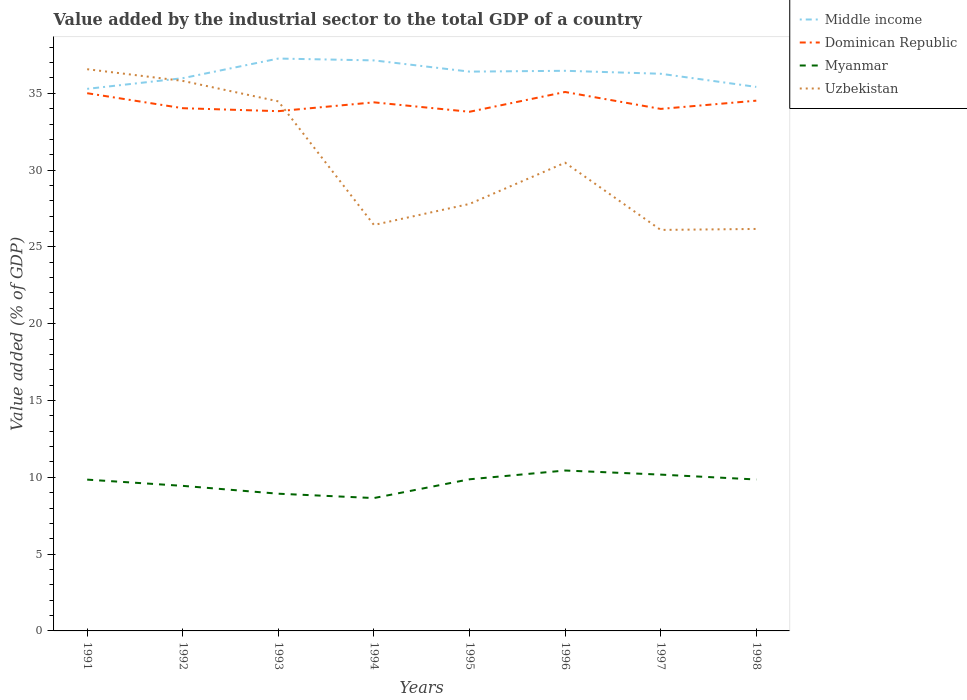How many different coloured lines are there?
Provide a succinct answer. 4. Does the line corresponding to Uzbekistan intersect with the line corresponding to Dominican Republic?
Make the answer very short. Yes. Is the number of lines equal to the number of legend labels?
Ensure brevity in your answer.  Yes. Across all years, what is the maximum value added by the industrial sector to the total GDP in Uzbekistan?
Offer a terse response. 26.11. What is the total value added by the industrial sector to the total GDP in Middle income in the graph?
Ensure brevity in your answer.  1.73. What is the difference between the highest and the second highest value added by the industrial sector to the total GDP in Uzbekistan?
Provide a succinct answer. 10.46. What is the difference between the highest and the lowest value added by the industrial sector to the total GDP in Dominican Republic?
Make the answer very short. 4. Does the graph contain grids?
Offer a very short reply. No. Where does the legend appear in the graph?
Keep it short and to the point. Top right. How many legend labels are there?
Offer a terse response. 4. What is the title of the graph?
Keep it short and to the point. Value added by the industrial sector to the total GDP of a country. Does "Lebanon" appear as one of the legend labels in the graph?
Your answer should be compact. No. What is the label or title of the Y-axis?
Make the answer very short. Value added (% of GDP). What is the Value added (% of GDP) in Middle income in 1991?
Your answer should be compact. 35.29. What is the Value added (% of GDP) in Dominican Republic in 1991?
Ensure brevity in your answer.  35. What is the Value added (% of GDP) in Myanmar in 1991?
Offer a terse response. 9.85. What is the Value added (% of GDP) in Uzbekistan in 1991?
Your answer should be compact. 36.57. What is the Value added (% of GDP) in Middle income in 1992?
Offer a very short reply. 35.98. What is the Value added (% of GDP) in Dominican Republic in 1992?
Make the answer very short. 34.03. What is the Value added (% of GDP) in Myanmar in 1992?
Make the answer very short. 9.44. What is the Value added (% of GDP) of Uzbekistan in 1992?
Your response must be concise. 35.81. What is the Value added (% of GDP) in Middle income in 1993?
Ensure brevity in your answer.  37.26. What is the Value added (% of GDP) in Dominican Republic in 1993?
Your answer should be compact. 33.84. What is the Value added (% of GDP) in Myanmar in 1993?
Give a very brief answer. 8.93. What is the Value added (% of GDP) in Uzbekistan in 1993?
Provide a succinct answer. 34.47. What is the Value added (% of GDP) of Middle income in 1994?
Make the answer very short. 37.14. What is the Value added (% of GDP) in Dominican Republic in 1994?
Your answer should be very brief. 34.41. What is the Value added (% of GDP) of Myanmar in 1994?
Your answer should be very brief. 8.65. What is the Value added (% of GDP) of Uzbekistan in 1994?
Make the answer very short. 26.43. What is the Value added (% of GDP) in Middle income in 1995?
Make the answer very short. 36.41. What is the Value added (% of GDP) in Dominican Republic in 1995?
Your answer should be very brief. 33.8. What is the Value added (% of GDP) in Myanmar in 1995?
Provide a short and direct response. 9.87. What is the Value added (% of GDP) in Uzbekistan in 1995?
Keep it short and to the point. 27.8. What is the Value added (% of GDP) in Middle income in 1996?
Keep it short and to the point. 36.46. What is the Value added (% of GDP) of Dominican Republic in 1996?
Keep it short and to the point. 35.08. What is the Value added (% of GDP) of Myanmar in 1996?
Your answer should be very brief. 10.44. What is the Value added (% of GDP) of Uzbekistan in 1996?
Your response must be concise. 30.48. What is the Value added (% of GDP) in Middle income in 1997?
Keep it short and to the point. 36.27. What is the Value added (% of GDP) of Dominican Republic in 1997?
Provide a short and direct response. 33.98. What is the Value added (% of GDP) of Myanmar in 1997?
Ensure brevity in your answer.  10.18. What is the Value added (% of GDP) of Uzbekistan in 1997?
Give a very brief answer. 26.11. What is the Value added (% of GDP) of Middle income in 1998?
Offer a very short reply. 35.42. What is the Value added (% of GDP) of Dominican Republic in 1998?
Give a very brief answer. 34.52. What is the Value added (% of GDP) of Myanmar in 1998?
Provide a succinct answer. 9.86. What is the Value added (% of GDP) in Uzbekistan in 1998?
Your answer should be very brief. 26.17. Across all years, what is the maximum Value added (% of GDP) of Middle income?
Offer a very short reply. 37.26. Across all years, what is the maximum Value added (% of GDP) of Dominican Republic?
Make the answer very short. 35.08. Across all years, what is the maximum Value added (% of GDP) in Myanmar?
Give a very brief answer. 10.44. Across all years, what is the maximum Value added (% of GDP) of Uzbekistan?
Make the answer very short. 36.57. Across all years, what is the minimum Value added (% of GDP) of Middle income?
Ensure brevity in your answer.  35.29. Across all years, what is the minimum Value added (% of GDP) of Dominican Republic?
Provide a short and direct response. 33.8. Across all years, what is the minimum Value added (% of GDP) of Myanmar?
Your answer should be very brief. 8.65. Across all years, what is the minimum Value added (% of GDP) of Uzbekistan?
Offer a very short reply. 26.11. What is the total Value added (% of GDP) in Middle income in the graph?
Provide a succinct answer. 290.23. What is the total Value added (% of GDP) in Dominican Republic in the graph?
Give a very brief answer. 274.66. What is the total Value added (% of GDP) in Myanmar in the graph?
Give a very brief answer. 77.22. What is the total Value added (% of GDP) of Uzbekistan in the graph?
Offer a very short reply. 243.83. What is the difference between the Value added (% of GDP) in Middle income in 1991 and that in 1992?
Ensure brevity in your answer.  -0.7. What is the difference between the Value added (% of GDP) in Dominican Republic in 1991 and that in 1992?
Keep it short and to the point. 0.98. What is the difference between the Value added (% of GDP) in Myanmar in 1991 and that in 1992?
Ensure brevity in your answer.  0.41. What is the difference between the Value added (% of GDP) of Uzbekistan in 1991 and that in 1992?
Offer a terse response. 0.76. What is the difference between the Value added (% of GDP) in Middle income in 1991 and that in 1993?
Make the answer very short. -1.97. What is the difference between the Value added (% of GDP) in Dominican Republic in 1991 and that in 1993?
Make the answer very short. 1.17. What is the difference between the Value added (% of GDP) of Myanmar in 1991 and that in 1993?
Keep it short and to the point. 0.92. What is the difference between the Value added (% of GDP) of Uzbekistan in 1991 and that in 1993?
Provide a short and direct response. 2.09. What is the difference between the Value added (% of GDP) of Middle income in 1991 and that in 1994?
Provide a short and direct response. -1.85. What is the difference between the Value added (% of GDP) of Dominican Republic in 1991 and that in 1994?
Provide a short and direct response. 0.59. What is the difference between the Value added (% of GDP) of Uzbekistan in 1991 and that in 1994?
Offer a very short reply. 10.14. What is the difference between the Value added (% of GDP) in Middle income in 1991 and that in 1995?
Offer a very short reply. -1.12. What is the difference between the Value added (% of GDP) in Dominican Republic in 1991 and that in 1995?
Provide a short and direct response. 1.21. What is the difference between the Value added (% of GDP) in Myanmar in 1991 and that in 1995?
Your response must be concise. -0.02. What is the difference between the Value added (% of GDP) of Uzbekistan in 1991 and that in 1995?
Your answer should be very brief. 8.77. What is the difference between the Value added (% of GDP) in Middle income in 1991 and that in 1996?
Provide a short and direct response. -1.18. What is the difference between the Value added (% of GDP) in Dominican Republic in 1991 and that in 1996?
Offer a terse response. -0.08. What is the difference between the Value added (% of GDP) of Myanmar in 1991 and that in 1996?
Ensure brevity in your answer.  -0.59. What is the difference between the Value added (% of GDP) in Uzbekistan in 1991 and that in 1996?
Give a very brief answer. 6.09. What is the difference between the Value added (% of GDP) in Middle income in 1991 and that in 1997?
Your answer should be very brief. -0.98. What is the difference between the Value added (% of GDP) in Dominican Republic in 1991 and that in 1997?
Your response must be concise. 1.02. What is the difference between the Value added (% of GDP) of Myanmar in 1991 and that in 1997?
Make the answer very short. -0.33. What is the difference between the Value added (% of GDP) of Uzbekistan in 1991 and that in 1997?
Provide a short and direct response. 10.46. What is the difference between the Value added (% of GDP) in Middle income in 1991 and that in 1998?
Ensure brevity in your answer.  -0.13. What is the difference between the Value added (% of GDP) in Dominican Republic in 1991 and that in 1998?
Ensure brevity in your answer.  0.49. What is the difference between the Value added (% of GDP) in Myanmar in 1991 and that in 1998?
Give a very brief answer. -0.01. What is the difference between the Value added (% of GDP) of Uzbekistan in 1991 and that in 1998?
Provide a succinct answer. 10.4. What is the difference between the Value added (% of GDP) in Middle income in 1992 and that in 1993?
Offer a very short reply. -1.28. What is the difference between the Value added (% of GDP) in Dominican Republic in 1992 and that in 1993?
Provide a succinct answer. 0.19. What is the difference between the Value added (% of GDP) of Myanmar in 1992 and that in 1993?
Offer a terse response. 0.51. What is the difference between the Value added (% of GDP) in Uzbekistan in 1992 and that in 1993?
Your response must be concise. 1.33. What is the difference between the Value added (% of GDP) of Middle income in 1992 and that in 1994?
Keep it short and to the point. -1.16. What is the difference between the Value added (% of GDP) of Dominican Republic in 1992 and that in 1994?
Give a very brief answer. -0.38. What is the difference between the Value added (% of GDP) in Myanmar in 1992 and that in 1994?
Your answer should be very brief. 0.79. What is the difference between the Value added (% of GDP) in Uzbekistan in 1992 and that in 1994?
Ensure brevity in your answer.  9.38. What is the difference between the Value added (% of GDP) of Middle income in 1992 and that in 1995?
Give a very brief answer. -0.43. What is the difference between the Value added (% of GDP) of Dominican Republic in 1992 and that in 1995?
Provide a short and direct response. 0.23. What is the difference between the Value added (% of GDP) of Myanmar in 1992 and that in 1995?
Make the answer very short. -0.43. What is the difference between the Value added (% of GDP) of Uzbekistan in 1992 and that in 1995?
Your answer should be very brief. 8.01. What is the difference between the Value added (% of GDP) of Middle income in 1992 and that in 1996?
Provide a short and direct response. -0.48. What is the difference between the Value added (% of GDP) of Dominican Republic in 1992 and that in 1996?
Your answer should be very brief. -1.06. What is the difference between the Value added (% of GDP) in Myanmar in 1992 and that in 1996?
Offer a very short reply. -1. What is the difference between the Value added (% of GDP) in Uzbekistan in 1992 and that in 1996?
Your answer should be compact. 5.33. What is the difference between the Value added (% of GDP) in Middle income in 1992 and that in 1997?
Offer a very short reply. -0.29. What is the difference between the Value added (% of GDP) in Dominican Republic in 1992 and that in 1997?
Provide a short and direct response. 0.05. What is the difference between the Value added (% of GDP) in Myanmar in 1992 and that in 1997?
Provide a succinct answer. -0.73. What is the difference between the Value added (% of GDP) of Uzbekistan in 1992 and that in 1997?
Make the answer very short. 9.7. What is the difference between the Value added (% of GDP) in Middle income in 1992 and that in 1998?
Your answer should be compact. 0.57. What is the difference between the Value added (% of GDP) of Dominican Republic in 1992 and that in 1998?
Ensure brevity in your answer.  -0.49. What is the difference between the Value added (% of GDP) in Myanmar in 1992 and that in 1998?
Provide a short and direct response. -0.41. What is the difference between the Value added (% of GDP) in Uzbekistan in 1992 and that in 1998?
Your answer should be very brief. 9.64. What is the difference between the Value added (% of GDP) of Middle income in 1993 and that in 1994?
Provide a short and direct response. 0.12. What is the difference between the Value added (% of GDP) in Dominican Republic in 1993 and that in 1994?
Your response must be concise. -0.57. What is the difference between the Value added (% of GDP) in Myanmar in 1993 and that in 1994?
Your answer should be very brief. 0.28. What is the difference between the Value added (% of GDP) in Uzbekistan in 1993 and that in 1994?
Make the answer very short. 8.05. What is the difference between the Value added (% of GDP) in Middle income in 1993 and that in 1995?
Give a very brief answer. 0.85. What is the difference between the Value added (% of GDP) of Dominican Republic in 1993 and that in 1995?
Keep it short and to the point. 0.04. What is the difference between the Value added (% of GDP) of Myanmar in 1993 and that in 1995?
Provide a succinct answer. -0.94. What is the difference between the Value added (% of GDP) in Uzbekistan in 1993 and that in 1995?
Your response must be concise. 6.68. What is the difference between the Value added (% of GDP) of Middle income in 1993 and that in 1996?
Provide a succinct answer. 0.8. What is the difference between the Value added (% of GDP) of Dominican Republic in 1993 and that in 1996?
Provide a succinct answer. -1.25. What is the difference between the Value added (% of GDP) of Myanmar in 1993 and that in 1996?
Provide a short and direct response. -1.51. What is the difference between the Value added (% of GDP) in Uzbekistan in 1993 and that in 1996?
Make the answer very short. 3.99. What is the difference between the Value added (% of GDP) in Dominican Republic in 1993 and that in 1997?
Give a very brief answer. -0.15. What is the difference between the Value added (% of GDP) in Myanmar in 1993 and that in 1997?
Keep it short and to the point. -1.24. What is the difference between the Value added (% of GDP) of Uzbekistan in 1993 and that in 1997?
Your response must be concise. 8.37. What is the difference between the Value added (% of GDP) of Middle income in 1993 and that in 1998?
Give a very brief answer. 1.85. What is the difference between the Value added (% of GDP) in Dominican Republic in 1993 and that in 1998?
Your answer should be compact. -0.68. What is the difference between the Value added (% of GDP) of Myanmar in 1993 and that in 1998?
Provide a short and direct response. -0.93. What is the difference between the Value added (% of GDP) in Uzbekistan in 1993 and that in 1998?
Ensure brevity in your answer.  8.31. What is the difference between the Value added (% of GDP) in Middle income in 1994 and that in 1995?
Provide a short and direct response. 0.73. What is the difference between the Value added (% of GDP) in Dominican Republic in 1994 and that in 1995?
Your answer should be compact. 0.61. What is the difference between the Value added (% of GDP) of Myanmar in 1994 and that in 1995?
Your answer should be very brief. -1.22. What is the difference between the Value added (% of GDP) of Uzbekistan in 1994 and that in 1995?
Keep it short and to the point. -1.37. What is the difference between the Value added (% of GDP) of Middle income in 1994 and that in 1996?
Provide a short and direct response. 0.68. What is the difference between the Value added (% of GDP) of Dominican Republic in 1994 and that in 1996?
Provide a short and direct response. -0.67. What is the difference between the Value added (% of GDP) in Myanmar in 1994 and that in 1996?
Your answer should be compact. -1.79. What is the difference between the Value added (% of GDP) in Uzbekistan in 1994 and that in 1996?
Offer a terse response. -4.05. What is the difference between the Value added (% of GDP) of Middle income in 1994 and that in 1997?
Keep it short and to the point. 0.87. What is the difference between the Value added (% of GDP) in Dominican Republic in 1994 and that in 1997?
Provide a succinct answer. 0.43. What is the difference between the Value added (% of GDP) in Myanmar in 1994 and that in 1997?
Your response must be concise. -1.53. What is the difference between the Value added (% of GDP) in Uzbekistan in 1994 and that in 1997?
Ensure brevity in your answer.  0.32. What is the difference between the Value added (% of GDP) in Middle income in 1994 and that in 1998?
Give a very brief answer. 1.73. What is the difference between the Value added (% of GDP) of Dominican Republic in 1994 and that in 1998?
Offer a very short reply. -0.11. What is the difference between the Value added (% of GDP) of Myanmar in 1994 and that in 1998?
Keep it short and to the point. -1.21. What is the difference between the Value added (% of GDP) in Uzbekistan in 1994 and that in 1998?
Your answer should be compact. 0.26. What is the difference between the Value added (% of GDP) of Middle income in 1995 and that in 1996?
Make the answer very short. -0.05. What is the difference between the Value added (% of GDP) of Dominican Republic in 1995 and that in 1996?
Ensure brevity in your answer.  -1.29. What is the difference between the Value added (% of GDP) in Myanmar in 1995 and that in 1996?
Ensure brevity in your answer.  -0.57. What is the difference between the Value added (% of GDP) of Uzbekistan in 1995 and that in 1996?
Provide a short and direct response. -2.68. What is the difference between the Value added (% of GDP) in Middle income in 1995 and that in 1997?
Make the answer very short. 0.14. What is the difference between the Value added (% of GDP) of Dominican Republic in 1995 and that in 1997?
Provide a succinct answer. -0.19. What is the difference between the Value added (% of GDP) of Myanmar in 1995 and that in 1997?
Your answer should be compact. -0.3. What is the difference between the Value added (% of GDP) of Uzbekistan in 1995 and that in 1997?
Make the answer very short. 1.69. What is the difference between the Value added (% of GDP) of Dominican Republic in 1995 and that in 1998?
Offer a very short reply. -0.72. What is the difference between the Value added (% of GDP) of Myanmar in 1995 and that in 1998?
Your response must be concise. 0.01. What is the difference between the Value added (% of GDP) in Uzbekistan in 1995 and that in 1998?
Your answer should be very brief. 1.63. What is the difference between the Value added (% of GDP) in Middle income in 1996 and that in 1997?
Offer a very short reply. 0.19. What is the difference between the Value added (% of GDP) of Dominican Republic in 1996 and that in 1997?
Your answer should be very brief. 1.1. What is the difference between the Value added (% of GDP) of Myanmar in 1996 and that in 1997?
Ensure brevity in your answer.  0.27. What is the difference between the Value added (% of GDP) in Uzbekistan in 1996 and that in 1997?
Offer a very short reply. 4.38. What is the difference between the Value added (% of GDP) of Middle income in 1996 and that in 1998?
Your response must be concise. 1.05. What is the difference between the Value added (% of GDP) of Dominican Republic in 1996 and that in 1998?
Your answer should be very brief. 0.57. What is the difference between the Value added (% of GDP) of Myanmar in 1996 and that in 1998?
Your response must be concise. 0.58. What is the difference between the Value added (% of GDP) in Uzbekistan in 1996 and that in 1998?
Provide a short and direct response. 4.31. What is the difference between the Value added (% of GDP) of Middle income in 1997 and that in 1998?
Make the answer very short. 0.86. What is the difference between the Value added (% of GDP) of Dominican Republic in 1997 and that in 1998?
Make the answer very short. -0.54. What is the difference between the Value added (% of GDP) of Myanmar in 1997 and that in 1998?
Give a very brief answer. 0.32. What is the difference between the Value added (% of GDP) of Uzbekistan in 1997 and that in 1998?
Provide a succinct answer. -0.06. What is the difference between the Value added (% of GDP) of Middle income in 1991 and the Value added (% of GDP) of Dominican Republic in 1992?
Your answer should be compact. 1.26. What is the difference between the Value added (% of GDP) of Middle income in 1991 and the Value added (% of GDP) of Myanmar in 1992?
Offer a terse response. 25.84. What is the difference between the Value added (% of GDP) in Middle income in 1991 and the Value added (% of GDP) in Uzbekistan in 1992?
Offer a very short reply. -0.52. What is the difference between the Value added (% of GDP) in Dominican Republic in 1991 and the Value added (% of GDP) in Myanmar in 1992?
Make the answer very short. 25.56. What is the difference between the Value added (% of GDP) of Dominican Republic in 1991 and the Value added (% of GDP) of Uzbekistan in 1992?
Ensure brevity in your answer.  -0.8. What is the difference between the Value added (% of GDP) of Myanmar in 1991 and the Value added (% of GDP) of Uzbekistan in 1992?
Offer a very short reply. -25.96. What is the difference between the Value added (% of GDP) of Middle income in 1991 and the Value added (% of GDP) of Dominican Republic in 1993?
Provide a succinct answer. 1.45. What is the difference between the Value added (% of GDP) of Middle income in 1991 and the Value added (% of GDP) of Myanmar in 1993?
Your response must be concise. 26.36. What is the difference between the Value added (% of GDP) in Middle income in 1991 and the Value added (% of GDP) in Uzbekistan in 1993?
Provide a short and direct response. 0.81. What is the difference between the Value added (% of GDP) in Dominican Republic in 1991 and the Value added (% of GDP) in Myanmar in 1993?
Offer a very short reply. 26.07. What is the difference between the Value added (% of GDP) of Dominican Republic in 1991 and the Value added (% of GDP) of Uzbekistan in 1993?
Your answer should be compact. 0.53. What is the difference between the Value added (% of GDP) of Myanmar in 1991 and the Value added (% of GDP) of Uzbekistan in 1993?
Your answer should be compact. -24.62. What is the difference between the Value added (% of GDP) of Middle income in 1991 and the Value added (% of GDP) of Dominican Republic in 1994?
Provide a succinct answer. 0.88. What is the difference between the Value added (% of GDP) in Middle income in 1991 and the Value added (% of GDP) in Myanmar in 1994?
Your response must be concise. 26.64. What is the difference between the Value added (% of GDP) in Middle income in 1991 and the Value added (% of GDP) in Uzbekistan in 1994?
Provide a short and direct response. 8.86. What is the difference between the Value added (% of GDP) of Dominican Republic in 1991 and the Value added (% of GDP) of Myanmar in 1994?
Offer a terse response. 26.36. What is the difference between the Value added (% of GDP) in Dominican Republic in 1991 and the Value added (% of GDP) in Uzbekistan in 1994?
Ensure brevity in your answer.  8.58. What is the difference between the Value added (% of GDP) of Myanmar in 1991 and the Value added (% of GDP) of Uzbekistan in 1994?
Your response must be concise. -16.58. What is the difference between the Value added (% of GDP) in Middle income in 1991 and the Value added (% of GDP) in Dominican Republic in 1995?
Give a very brief answer. 1.49. What is the difference between the Value added (% of GDP) of Middle income in 1991 and the Value added (% of GDP) of Myanmar in 1995?
Provide a succinct answer. 25.42. What is the difference between the Value added (% of GDP) in Middle income in 1991 and the Value added (% of GDP) in Uzbekistan in 1995?
Your response must be concise. 7.49. What is the difference between the Value added (% of GDP) of Dominican Republic in 1991 and the Value added (% of GDP) of Myanmar in 1995?
Give a very brief answer. 25.13. What is the difference between the Value added (% of GDP) of Dominican Republic in 1991 and the Value added (% of GDP) of Uzbekistan in 1995?
Provide a short and direct response. 7.21. What is the difference between the Value added (% of GDP) of Myanmar in 1991 and the Value added (% of GDP) of Uzbekistan in 1995?
Your answer should be very brief. -17.95. What is the difference between the Value added (% of GDP) of Middle income in 1991 and the Value added (% of GDP) of Dominican Republic in 1996?
Offer a very short reply. 0.2. What is the difference between the Value added (% of GDP) of Middle income in 1991 and the Value added (% of GDP) of Myanmar in 1996?
Make the answer very short. 24.85. What is the difference between the Value added (% of GDP) of Middle income in 1991 and the Value added (% of GDP) of Uzbekistan in 1996?
Offer a terse response. 4.81. What is the difference between the Value added (% of GDP) in Dominican Republic in 1991 and the Value added (% of GDP) in Myanmar in 1996?
Give a very brief answer. 24.56. What is the difference between the Value added (% of GDP) in Dominican Republic in 1991 and the Value added (% of GDP) in Uzbekistan in 1996?
Your answer should be compact. 4.52. What is the difference between the Value added (% of GDP) in Myanmar in 1991 and the Value added (% of GDP) in Uzbekistan in 1996?
Make the answer very short. -20.63. What is the difference between the Value added (% of GDP) in Middle income in 1991 and the Value added (% of GDP) in Dominican Republic in 1997?
Your answer should be compact. 1.3. What is the difference between the Value added (% of GDP) of Middle income in 1991 and the Value added (% of GDP) of Myanmar in 1997?
Make the answer very short. 25.11. What is the difference between the Value added (% of GDP) in Middle income in 1991 and the Value added (% of GDP) in Uzbekistan in 1997?
Your answer should be compact. 9.18. What is the difference between the Value added (% of GDP) in Dominican Republic in 1991 and the Value added (% of GDP) in Myanmar in 1997?
Provide a succinct answer. 24.83. What is the difference between the Value added (% of GDP) in Dominican Republic in 1991 and the Value added (% of GDP) in Uzbekistan in 1997?
Your answer should be very brief. 8.9. What is the difference between the Value added (% of GDP) in Myanmar in 1991 and the Value added (% of GDP) in Uzbekistan in 1997?
Give a very brief answer. -16.26. What is the difference between the Value added (% of GDP) in Middle income in 1991 and the Value added (% of GDP) in Dominican Republic in 1998?
Give a very brief answer. 0.77. What is the difference between the Value added (% of GDP) of Middle income in 1991 and the Value added (% of GDP) of Myanmar in 1998?
Offer a very short reply. 25.43. What is the difference between the Value added (% of GDP) of Middle income in 1991 and the Value added (% of GDP) of Uzbekistan in 1998?
Offer a terse response. 9.12. What is the difference between the Value added (% of GDP) in Dominican Republic in 1991 and the Value added (% of GDP) in Myanmar in 1998?
Your answer should be very brief. 25.15. What is the difference between the Value added (% of GDP) in Dominican Republic in 1991 and the Value added (% of GDP) in Uzbekistan in 1998?
Keep it short and to the point. 8.84. What is the difference between the Value added (% of GDP) in Myanmar in 1991 and the Value added (% of GDP) in Uzbekistan in 1998?
Offer a very short reply. -16.32. What is the difference between the Value added (% of GDP) in Middle income in 1992 and the Value added (% of GDP) in Dominican Republic in 1993?
Provide a succinct answer. 2.15. What is the difference between the Value added (% of GDP) in Middle income in 1992 and the Value added (% of GDP) in Myanmar in 1993?
Keep it short and to the point. 27.05. What is the difference between the Value added (% of GDP) of Middle income in 1992 and the Value added (% of GDP) of Uzbekistan in 1993?
Ensure brevity in your answer.  1.51. What is the difference between the Value added (% of GDP) in Dominican Republic in 1992 and the Value added (% of GDP) in Myanmar in 1993?
Provide a succinct answer. 25.1. What is the difference between the Value added (% of GDP) of Dominican Republic in 1992 and the Value added (% of GDP) of Uzbekistan in 1993?
Your response must be concise. -0.45. What is the difference between the Value added (% of GDP) of Myanmar in 1992 and the Value added (% of GDP) of Uzbekistan in 1993?
Ensure brevity in your answer.  -25.03. What is the difference between the Value added (% of GDP) of Middle income in 1992 and the Value added (% of GDP) of Dominican Republic in 1994?
Ensure brevity in your answer.  1.57. What is the difference between the Value added (% of GDP) of Middle income in 1992 and the Value added (% of GDP) of Myanmar in 1994?
Offer a very short reply. 27.33. What is the difference between the Value added (% of GDP) of Middle income in 1992 and the Value added (% of GDP) of Uzbekistan in 1994?
Your response must be concise. 9.55. What is the difference between the Value added (% of GDP) of Dominican Republic in 1992 and the Value added (% of GDP) of Myanmar in 1994?
Provide a succinct answer. 25.38. What is the difference between the Value added (% of GDP) of Dominican Republic in 1992 and the Value added (% of GDP) of Uzbekistan in 1994?
Provide a succinct answer. 7.6. What is the difference between the Value added (% of GDP) in Myanmar in 1992 and the Value added (% of GDP) in Uzbekistan in 1994?
Give a very brief answer. -16.98. What is the difference between the Value added (% of GDP) of Middle income in 1992 and the Value added (% of GDP) of Dominican Republic in 1995?
Keep it short and to the point. 2.19. What is the difference between the Value added (% of GDP) in Middle income in 1992 and the Value added (% of GDP) in Myanmar in 1995?
Your answer should be compact. 26.11. What is the difference between the Value added (% of GDP) in Middle income in 1992 and the Value added (% of GDP) in Uzbekistan in 1995?
Your response must be concise. 8.19. What is the difference between the Value added (% of GDP) in Dominican Republic in 1992 and the Value added (% of GDP) in Myanmar in 1995?
Keep it short and to the point. 24.16. What is the difference between the Value added (% of GDP) in Dominican Republic in 1992 and the Value added (% of GDP) in Uzbekistan in 1995?
Your answer should be compact. 6.23. What is the difference between the Value added (% of GDP) of Myanmar in 1992 and the Value added (% of GDP) of Uzbekistan in 1995?
Make the answer very short. -18.35. What is the difference between the Value added (% of GDP) in Middle income in 1992 and the Value added (% of GDP) in Dominican Republic in 1996?
Your answer should be very brief. 0.9. What is the difference between the Value added (% of GDP) in Middle income in 1992 and the Value added (% of GDP) in Myanmar in 1996?
Make the answer very short. 25.54. What is the difference between the Value added (% of GDP) in Middle income in 1992 and the Value added (% of GDP) in Uzbekistan in 1996?
Your response must be concise. 5.5. What is the difference between the Value added (% of GDP) in Dominican Republic in 1992 and the Value added (% of GDP) in Myanmar in 1996?
Offer a terse response. 23.59. What is the difference between the Value added (% of GDP) in Dominican Republic in 1992 and the Value added (% of GDP) in Uzbekistan in 1996?
Give a very brief answer. 3.55. What is the difference between the Value added (% of GDP) in Myanmar in 1992 and the Value added (% of GDP) in Uzbekistan in 1996?
Your response must be concise. -21.04. What is the difference between the Value added (% of GDP) of Middle income in 1992 and the Value added (% of GDP) of Dominican Republic in 1997?
Give a very brief answer. 2. What is the difference between the Value added (% of GDP) of Middle income in 1992 and the Value added (% of GDP) of Myanmar in 1997?
Your response must be concise. 25.81. What is the difference between the Value added (% of GDP) in Middle income in 1992 and the Value added (% of GDP) in Uzbekistan in 1997?
Your answer should be very brief. 9.88. What is the difference between the Value added (% of GDP) of Dominican Republic in 1992 and the Value added (% of GDP) of Myanmar in 1997?
Provide a succinct answer. 23.85. What is the difference between the Value added (% of GDP) of Dominican Republic in 1992 and the Value added (% of GDP) of Uzbekistan in 1997?
Ensure brevity in your answer.  7.92. What is the difference between the Value added (% of GDP) in Myanmar in 1992 and the Value added (% of GDP) in Uzbekistan in 1997?
Keep it short and to the point. -16.66. What is the difference between the Value added (% of GDP) in Middle income in 1992 and the Value added (% of GDP) in Dominican Republic in 1998?
Your answer should be compact. 1.46. What is the difference between the Value added (% of GDP) in Middle income in 1992 and the Value added (% of GDP) in Myanmar in 1998?
Ensure brevity in your answer.  26.13. What is the difference between the Value added (% of GDP) of Middle income in 1992 and the Value added (% of GDP) of Uzbekistan in 1998?
Offer a very short reply. 9.82. What is the difference between the Value added (% of GDP) in Dominican Republic in 1992 and the Value added (% of GDP) in Myanmar in 1998?
Provide a short and direct response. 24.17. What is the difference between the Value added (% of GDP) of Dominican Republic in 1992 and the Value added (% of GDP) of Uzbekistan in 1998?
Give a very brief answer. 7.86. What is the difference between the Value added (% of GDP) in Myanmar in 1992 and the Value added (% of GDP) in Uzbekistan in 1998?
Your answer should be compact. -16.72. What is the difference between the Value added (% of GDP) in Middle income in 1993 and the Value added (% of GDP) in Dominican Republic in 1994?
Provide a short and direct response. 2.85. What is the difference between the Value added (% of GDP) of Middle income in 1993 and the Value added (% of GDP) of Myanmar in 1994?
Give a very brief answer. 28.61. What is the difference between the Value added (% of GDP) in Middle income in 1993 and the Value added (% of GDP) in Uzbekistan in 1994?
Your answer should be very brief. 10.83. What is the difference between the Value added (% of GDP) of Dominican Republic in 1993 and the Value added (% of GDP) of Myanmar in 1994?
Ensure brevity in your answer.  25.19. What is the difference between the Value added (% of GDP) of Dominican Republic in 1993 and the Value added (% of GDP) of Uzbekistan in 1994?
Provide a succinct answer. 7.41. What is the difference between the Value added (% of GDP) in Myanmar in 1993 and the Value added (% of GDP) in Uzbekistan in 1994?
Keep it short and to the point. -17.5. What is the difference between the Value added (% of GDP) of Middle income in 1993 and the Value added (% of GDP) of Dominican Republic in 1995?
Provide a short and direct response. 3.46. What is the difference between the Value added (% of GDP) in Middle income in 1993 and the Value added (% of GDP) in Myanmar in 1995?
Your response must be concise. 27.39. What is the difference between the Value added (% of GDP) in Middle income in 1993 and the Value added (% of GDP) in Uzbekistan in 1995?
Provide a short and direct response. 9.46. What is the difference between the Value added (% of GDP) of Dominican Republic in 1993 and the Value added (% of GDP) of Myanmar in 1995?
Offer a terse response. 23.96. What is the difference between the Value added (% of GDP) of Dominican Republic in 1993 and the Value added (% of GDP) of Uzbekistan in 1995?
Make the answer very short. 6.04. What is the difference between the Value added (% of GDP) of Myanmar in 1993 and the Value added (% of GDP) of Uzbekistan in 1995?
Provide a short and direct response. -18.86. What is the difference between the Value added (% of GDP) of Middle income in 1993 and the Value added (% of GDP) of Dominican Republic in 1996?
Provide a succinct answer. 2.18. What is the difference between the Value added (% of GDP) in Middle income in 1993 and the Value added (% of GDP) in Myanmar in 1996?
Ensure brevity in your answer.  26.82. What is the difference between the Value added (% of GDP) of Middle income in 1993 and the Value added (% of GDP) of Uzbekistan in 1996?
Provide a succinct answer. 6.78. What is the difference between the Value added (% of GDP) in Dominican Republic in 1993 and the Value added (% of GDP) in Myanmar in 1996?
Give a very brief answer. 23.39. What is the difference between the Value added (% of GDP) of Dominican Republic in 1993 and the Value added (% of GDP) of Uzbekistan in 1996?
Your answer should be compact. 3.35. What is the difference between the Value added (% of GDP) in Myanmar in 1993 and the Value added (% of GDP) in Uzbekistan in 1996?
Make the answer very short. -21.55. What is the difference between the Value added (% of GDP) in Middle income in 1993 and the Value added (% of GDP) in Dominican Republic in 1997?
Ensure brevity in your answer.  3.28. What is the difference between the Value added (% of GDP) of Middle income in 1993 and the Value added (% of GDP) of Myanmar in 1997?
Provide a succinct answer. 27.09. What is the difference between the Value added (% of GDP) in Middle income in 1993 and the Value added (% of GDP) in Uzbekistan in 1997?
Your answer should be very brief. 11.16. What is the difference between the Value added (% of GDP) in Dominican Republic in 1993 and the Value added (% of GDP) in Myanmar in 1997?
Offer a terse response. 23.66. What is the difference between the Value added (% of GDP) of Dominican Republic in 1993 and the Value added (% of GDP) of Uzbekistan in 1997?
Provide a short and direct response. 7.73. What is the difference between the Value added (% of GDP) of Myanmar in 1993 and the Value added (% of GDP) of Uzbekistan in 1997?
Make the answer very short. -17.17. What is the difference between the Value added (% of GDP) in Middle income in 1993 and the Value added (% of GDP) in Dominican Republic in 1998?
Your answer should be very brief. 2.74. What is the difference between the Value added (% of GDP) of Middle income in 1993 and the Value added (% of GDP) of Myanmar in 1998?
Provide a succinct answer. 27.4. What is the difference between the Value added (% of GDP) in Middle income in 1993 and the Value added (% of GDP) in Uzbekistan in 1998?
Offer a terse response. 11.09. What is the difference between the Value added (% of GDP) in Dominican Republic in 1993 and the Value added (% of GDP) in Myanmar in 1998?
Offer a very short reply. 23.98. What is the difference between the Value added (% of GDP) of Dominican Republic in 1993 and the Value added (% of GDP) of Uzbekistan in 1998?
Your answer should be very brief. 7.67. What is the difference between the Value added (% of GDP) of Myanmar in 1993 and the Value added (% of GDP) of Uzbekistan in 1998?
Your response must be concise. -17.24. What is the difference between the Value added (% of GDP) in Middle income in 1994 and the Value added (% of GDP) in Dominican Republic in 1995?
Make the answer very short. 3.34. What is the difference between the Value added (% of GDP) in Middle income in 1994 and the Value added (% of GDP) in Myanmar in 1995?
Provide a succinct answer. 27.27. What is the difference between the Value added (% of GDP) in Middle income in 1994 and the Value added (% of GDP) in Uzbekistan in 1995?
Your response must be concise. 9.34. What is the difference between the Value added (% of GDP) of Dominican Republic in 1994 and the Value added (% of GDP) of Myanmar in 1995?
Offer a very short reply. 24.54. What is the difference between the Value added (% of GDP) in Dominican Republic in 1994 and the Value added (% of GDP) in Uzbekistan in 1995?
Offer a very short reply. 6.61. What is the difference between the Value added (% of GDP) in Myanmar in 1994 and the Value added (% of GDP) in Uzbekistan in 1995?
Ensure brevity in your answer.  -19.15. What is the difference between the Value added (% of GDP) of Middle income in 1994 and the Value added (% of GDP) of Dominican Republic in 1996?
Provide a succinct answer. 2.06. What is the difference between the Value added (% of GDP) of Middle income in 1994 and the Value added (% of GDP) of Myanmar in 1996?
Make the answer very short. 26.7. What is the difference between the Value added (% of GDP) of Middle income in 1994 and the Value added (% of GDP) of Uzbekistan in 1996?
Offer a very short reply. 6.66. What is the difference between the Value added (% of GDP) of Dominican Republic in 1994 and the Value added (% of GDP) of Myanmar in 1996?
Offer a very short reply. 23.97. What is the difference between the Value added (% of GDP) in Dominican Republic in 1994 and the Value added (% of GDP) in Uzbekistan in 1996?
Offer a terse response. 3.93. What is the difference between the Value added (% of GDP) in Myanmar in 1994 and the Value added (% of GDP) in Uzbekistan in 1996?
Provide a succinct answer. -21.83. What is the difference between the Value added (% of GDP) in Middle income in 1994 and the Value added (% of GDP) in Dominican Republic in 1997?
Your response must be concise. 3.16. What is the difference between the Value added (% of GDP) of Middle income in 1994 and the Value added (% of GDP) of Myanmar in 1997?
Provide a short and direct response. 26.96. What is the difference between the Value added (% of GDP) in Middle income in 1994 and the Value added (% of GDP) in Uzbekistan in 1997?
Provide a succinct answer. 11.04. What is the difference between the Value added (% of GDP) in Dominican Republic in 1994 and the Value added (% of GDP) in Myanmar in 1997?
Ensure brevity in your answer.  24.23. What is the difference between the Value added (% of GDP) of Dominican Republic in 1994 and the Value added (% of GDP) of Uzbekistan in 1997?
Your response must be concise. 8.3. What is the difference between the Value added (% of GDP) of Myanmar in 1994 and the Value added (% of GDP) of Uzbekistan in 1997?
Offer a terse response. -17.46. What is the difference between the Value added (% of GDP) of Middle income in 1994 and the Value added (% of GDP) of Dominican Republic in 1998?
Your answer should be very brief. 2.62. What is the difference between the Value added (% of GDP) of Middle income in 1994 and the Value added (% of GDP) of Myanmar in 1998?
Your answer should be compact. 27.28. What is the difference between the Value added (% of GDP) in Middle income in 1994 and the Value added (% of GDP) in Uzbekistan in 1998?
Provide a short and direct response. 10.97. What is the difference between the Value added (% of GDP) of Dominican Republic in 1994 and the Value added (% of GDP) of Myanmar in 1998?
Your response must be concise. 24.55. What is the difference between the Value added (% of GDP) in Dominican Republic in 1994 and the Value added (% of GDP) in Uzbekistan in 1998?
Offer a terse response. 8.24. What is the difference between the Value added (% of GDP) of Myanmar in 1994 and the Value added (% of GDP) of Uzbekistan in 1998?
Your answer should be very brief. -17.52. What is the difference between the Value added (% of GDP) of Middle income in 1995 and the Value added (% of GDP) of Dominican Republic in 1996?
Your answer should be compact. 1.33. What is the difference between the Value added (% of GDP) of Middle income in 1995 and the Value added (% of GDP) of Myanmar in 1996?
Your response must be concise. 25.97. What is the difference between the Value added (% of GDP) in Middle income in 1995 and the Value added (% of GDP) in Uzbekistan in 1996?
Your answer should be compact. 5.93. What is the difference between the Value added (% of GDP) in Dominican Republic in 1995 and the Value added (% of GDP) in Myanmar in 1996?
Your answer should be compact. 23.35. What is the difference between the Value added (% of GDP) of Dominican Republic in 1995 and the Value added (% of GDP) of Uzbekistan in 1996?
Your answer should be very brief. 3.32. What is the difference between the Value added (% of GDP) in Myanmar in 1995 and the Value added (% of GDP) in Uzbekistan in 1996?
Offer a very short reply. -20.61. What is the difference between the Value added (% of GDP) of Middle income in 1995 and the Value added (% of GDP) of Dominican Republic in 1997?
Offer a very short reply. 2.43. What is the difference between the Value added (% of GDP) of Middle income in 1995 and the Value added (% of GDP) of Myanmar in 1997?
Offer a very short reply. 26.23. What is the difference between the Value added (% of GDP) in Middle income in 1995 and the Value added (% of GDP) in Uzbekistan in 1997?
Provide a short and direct response. 10.3. What is the difference between the Value added (% of GDP) in Dominican Republic in 1995 and the Value added (% of GDP) in Myanmar in 1997?
Your answer should be compact. 23.62. What is the difference between the Value added (% of GDP) in Dominican Republic in 1995 and the Value added (% of GDP) in Uzbekistan in 1997?
Provide a short and direct response. 7.69. What is the difference between the Value added (% of GDP) in Myanmar in 1995 and the Value added (% of GDP) in Uzbekistan in 1997?
Offer a terse response. -16.23. What is the difference between the Value added (% of GDP) of Middle income in 1995 and the Value added (% of GDP) of Dominican Republic in 1998?
Give a very brief answer. 1.89. What is the difference between the Value added (% of GDP) of Middle income in 1995 and the Value added (% of GDP) of Myanmar in 1998?
Provide a short and direct response. 26.55. What is the difference between the Value added (% of GDP) in Middle income in 1995 and the Value added (% of GDP) in Uzbekistan in 1998?
Give a very brief answer. 10.24. What is the difference between the Value added (% of GDP) in Dominican Republic in 1995 and the Value added (% of GDP) in Myanmar in 1998?
Make the answer very short. 23.94. What is the difference between the Value added (% of GDP) of Dominican Republic in 1995 and the Value added (% of GDP) of Uzbekistan in 1998?
Give a very brief answer. 7.63. What is the difference between the Value added (% of GDP) of Myanmar in 1995 and the Value added (% of GDP) of Uzbekistan in 1998?
Ensure brevity in your answer.  -16.3. What is the difference between the Value added (% of GDP) of Middle income in 1996 and the Value added (% of GDP) of Dominican Republic in 1997?
Offer a terse response. 2.48. What is the difference between the Value added (% of GDP) in Middle income in 1996 and the Value added (% of GDP) in Myanmar in 1997?
Make the answer very short. 26.29. What is the difference between the Value added (% of GDP) in Middle income in 1996 and the Value added (% of GDP) in Uzbekistan in 1997?
Your answer should be compact. 10.36. What is the difference between the Value added (% of GDP) of Dominican Republic in 1996 and the Value added (% of GDP) of Myanmar in 1997?
Offer a terse response. 24.91. What is the difference between the Value added (% of GDP) of Dominican Republic in 1996 and the Value added (% of GDP) of Uzbekistan in 1997?
Give a very brief answer. 8.98. What is the difference between the Value added (% of GDP) in Myanmar in 1996 and the Value added (% of GDP) in Uzbekistan in 1997?
Ensure brevity in your answer.  -15.66. What is the difference between the Value added (% of GDP) of Middle income in 1996 and the Value added (% of GDP) of Dominican Republic in 1998?
Your response must be concise. 1.95. What is the difference between the Value added (% of GDP) of Middle income in 1996 and the Value added (% of GDP) of Myanmar in 1998?
Your answer should be compact. 26.61. What is the difference between the Value added (% of GDP) of Middle income in 1996 and the Value added (% of GDP) of Uzbekistan in 1998?
Provide a succinct answer. 10.3. What is the difference between the Value added (% of GDP) in Dominican Republic in 1996 and the Value added (% of GDP) in Myanmar in 1998?
Ensure brevity in your answer.  25.23. What is the difference between the Value added (% of GDP) in Dominican Republic in 1996 and the Value added (% of GDP) in Uzbekistan in 1998?
Ensure brevity in your answer.  8.92. What is the difference between the Value added (% of GDP) in Myanmar in 1996 and the Value added (% of GDP) in Uzbekistan in 1998?
Your response must be concise. -15.73. What is the difference between the Value added (% of GDP) of Middle income in 1997 and the Value added (% of GDP) of Dominican Republic in 1998?
Give a very brief answer. 1.75. What is the difference between the Value added (% of GDP) of Middle income in 1997 and the Value added (% of GDP) of Myanmar in 1998?
Your answer should be very brief. 26.41. What is the difference between the Value added (% of GDP) of Middle income in 1997 and the Value added (% of GDP) of Uzbekistan in 1998?
Your response must be concise. 10.1. What is the difference between the Value added (% of GDP) in Dominican Republic in 1997 and the Value added (% of GDP) in Myanmar in 1998?
Ensure brevity in your answer.  24.12. What is the difference between the Value added (% of GDP) of Dominican Republic in 1997 and the Value added (% of GDP) of Uzbekistan in 1998?
Your answer should be compact. 7.81. What is the difference between the Value added (% of GDP) in Myanmar in 1997 and the Value added (% of GDP) in Uzbekistan in 1998?
Your response must be concise. -15.99. What is the average Value added (% of GDP) of Middle income per year?
Keep it short and to the point. 36.28. What is the average Value added (% of GDP) of Dominican Republic per year?
Provide a succinct answer. 34.33. What is the average Value added (% of GDP) of Myanmar per year?
Provide a succinct answer. 9.65. What is the average Value added (% of GDP) of Uzbekistan per year?
Offer a very short reply. 30.48. In the year 1991, what is the difference between the Value added (% of GDP) in Middle income and Value added (% of GDP) in Dominican Republic?
Make the answer very short. 0.28. In the year 1991, what is the difference between the Value added (% of GDP) of Middle income and Value added (% of GDP) of Myanmar?
Your answer should be very brief. 25.44. In the year 1991, what is the difference between the Value added (% of GDP) in Middle income and Value added (% of GDP) in Uzbekistan?
Your response must be concise. -1.28. In the year 1991, what is the difference between the Value added (% of GDP) in Dominican Republic and Value added (% of GDP) in Myanmar?
Provide a succinct answer. 25.16. In the year 1991, what is the difference between the Value added (% of GDP) of Dominican Republic and Value added (% of GDP) of Uzbekistan?
Your answer should be compact. -1.56. In the year 1991, what is the difference between the Value added (% of GDP) in Myanmar and Value added (% of GDP) in Uzbekistan?
Your response must be concise. -26.72. In the year 1992, what is the difference between the Value added (% of GDP) of Middle income and Value added (% of GDP) of Dominican Republic?
Provide a succinct answer. 1.96. In the year 1992, what is the difference between the Value added (% of GDP) of Middle income and Value added (% of GDP) of Myanmar?
Your response must be concise. 26.54. In the year 1992, what is the difference between the Value added (% of GDP) in Middle income and Value added (% of GDP) in Uzbekistan?
Offer a very short reply. 0.18. In the year 1992, what is the difference between the Value added (% of GDP) in Dominican Republic and Value added (% of GDP) in Myanmar?
Offer a terse response. 24.58. In the year 1992, what is the difference between the Value added (% of GDP) of Dominican Republic and Value added (% of GDP) of Uzbekistan?
Provide a short and direct response. -1.78. In the year 1992, what is the difference between the Value added (% of GDP) of Myanmar and Value added (% of GDP) of Uzbekistan?
Provide a succinct answer. -26.36. In the year 1993, what is the difference between the Value added (% of GDP) in Middle income and Value added (% of GDP) in Dominican Republic?
Offer a very short reply. 3.43. In the year 1993, what is the difference between the Value added (% of GDP) in Middle income and Value added (% of GDP) in Myanmar?
Provide a succinct answer. 28.33. In the year 1993, what is the difference between the Value added (% of GDP) of Middle income and Value added (% of GDP) of Uzbekistan?
Your answer should be compact. 2.79. In the year 1993, what is the difference between the Value added (% of GDP) in Dominican Republic and Value added (% of GDP) in Myanmar?
Provide a succinct answer. 24.9. In the year 1993, what is the difference between the Value added (% of GDP) in Dominican Republic and Value added (% of GDP) in Uzbekistan?
Offer a very short reply. -0.64. In the year 1993, what is the difference between the Value added (% of GDP) in Myanmar and Value added (% of GDP) in Uzbekistan?
Keep it short and to the point. -25.54. In the year 1994, what is the difference between the Value added (% of GDP) of Middle income and Value added (% of GDP) of Dominican Republic?
Ensure brevity in your answer.  2.73. In the year 1994, what is the difference between the Value added (% of GDP) in Middle income and Value added (% of GDP) in Myanmar?
Your answer should be very brief. 28.49. In the year 1994, what is the difference between the Value added (% of GDP) in Middle income and Value added (% of GDP) in Uzbekistan?
Ensure brevity in your answer.  10.71. In the year 1994, what is the difference between the Value added (% of GDP) of Dominican Republic and Value added (% of GDP) of Myanmar?
Offer a terse response. 25.76. In the year 1994, what is the difference between the Value added (% of GDP) in Dominican Republic and Value added (% of GDP) in Uzbekistan?
Give a very brief answer. 7.98. In the year 1994, what is the difference between the Value added (% of GDP) of Myanmar and Value added (% of GDP) of Uzbekistan?
Your response must be concise. -17.78. In the year 1995, what is the difference between the Value added (% of GDP) of Middle income and Value added (% of GDP) of Dominican Republic?
Make the answer very short. 2.61. In the year 1995, what is the difference between the Value added (% of GDP) in Middle income and Value added (% of GDP) in Myanmar?
Give a very brief answer. 26.54. In the year 1995, what is the difference between the Value added (% of GDP) in Middle income and Value added (% of GDP) in Uzbekistan?
Make the answer very short. 8.61. In the year 1995, what is the difference between the Value added (% of GDP) of Dominican Republic and Value added (% of GDP) of Myanmar?
Offer a very short reply. 23.93. In the year 1995, what is the difference between the Value added (% of GDP) in Dominican Republic and Value added (% of GDP) in Uzbekistan?
Make the answer very short. 6. In the year 1995, what is the difference between the Value added (% of GDP) in Myanmar and Value added (% of GDP) in Uzbekistan?
Offer a terse response. -17.93. In the year 1996, what is the difference between the Value added (% of GDP) in Middle income and Value added (% of GDP) in Dominican Republic?
Keep it short and to the point. 1.38. In the year 1996, what is the difference between the Value added (% of GDP) of Middle income and Value added (% of GDP) of Myanmar?
Give a very brief answer. 26.02. In the year 1996, what is the difference between the Value added (% of GDP) in Middle income and Value added (% of GDP) in Uzbekistan?
Provide a succinct answer. 5.98. In the year 1996, what is the difference between the Value added (% of GDP) of Dominican Republic and Value added (% of GDP) of Myanmar?
Ensure brevity in your answer.  24.64. In the year 1996, what is the difference between the Value added (% of GDP) in Dominican Republic and Value added (% of GDP) in Uzbekistan?
Provide a succinct answer. 4.6. In the year 1996, what is the difference between the Value added (% of GDP) of Myanmar and Value added (% of GDP) of Uzbekistan?
Your answer should be compact. -20.04. In the year 1997, what is the difference between the Value added (% of GDP) of Middle income and Value added (% of GDP) of Dominican Republic?
Keep it short and to the point. 2.29. In the year 1997, what is the difference between the Value added (% of GDP) of Middle income and Value added (% of GDP) of Myanmar?
Offer a terse response. 26.1. In the year 1997, what is the difference between the Value added (% of GDP) of Middle income and Value added (% of GDP) of Uzbekistan?
Offer a very short reply. 10.17. In the year 1997, what is the difference between the Value added (% of GDP) of Dominican Republic and Value added (% of GDP) of Myanmar?
Provide a succinct answer. 23.81. In the year 1997, what is the difference between the Value added (% of GDP) in Dominican Republic and Value added (% of GDP) in Uzbekistan?
Your response must be concise. 7.88. In the year 1997, what is the difference between the Value added (% of GDP) of Myanmar and Value added (% of GDP) of Uzbekistan?
Offer a very short reply. -15.93. In the year 1998, what is the difference between the Value added (% of GDP) in Middle income and Value added (% of GDP) in Dominican Republic?
Your answer should be compact. 0.9. In the year 1998, what is the difference between the Value added (% of GDP) in Middle income and Value added (% of GDP) in Myanmar?
Your answer should be compact. 25.56. In the year 1998, what is the difference between the Value added (% of GDP) of Middle income and Value added (% of GDP) of Uzbekistan?
Ensure brevity in your answer.  9.25. In the year 1998, what is the difference between the Value added (% of GDP) of Dominican Republic and Value added (% of GDP) of Myanmar?
Provide a short and direct response. 24.66. In the year 1998, what is the difference between the Value added (% of GDP) in Dominican Republic and Value added (% of GDP) in Uzbekistan?
Offer a terse response. 8.35. In the year 1998, what is the difference between the Value added (% of GDP) in Myanmar and Value added (% of GDP) in Uzbekistan?
Provide a succinct answer. -16.31. What is the ratio of the Value added (% of GDP) of Middle income in 1991 to that in 1992?
Your response must be concise. 0.98. What is the ratio of the Value added (% of GDP) of Dominican Republic in 1991 to that in 1992?
Keep it short and to the point. 1.03. What is the ratio of the Value added (% of GDP) of Myanmar in 1991 to that in 1992?
Your response must be concise. 1.04. What is the ratio of the Value added (% of GDP) in Uzbekistan in 1991 to that in 1992?
Ensure brevity in your answer.  1.02. What is the ratio of the Value added (% of GDP) in Middle income in 1991 to that in 1993?
Offer a terse response. 0.95. What is the ratio of the Value added (% of GDP) in Dominican Republic in 1991 to that in 1993?
Give a very brief answer. 1.03. What is the ratio of the Value added (% of GDP) in Myanmar in 1991 to that in 1993?
Make the answer very short. 1.1. What is the ratio of the Value added (% of GDP) of Uzbekistan in 1991 to that in 1993?
Ensure brevity in your answer.  1.06. What is the ratio of the Value added (% of GDP) in Middle income in 1991 to that in 1994?
Provide a succinct answer. 0.95. What is the ratio of the Value added (% of GDP) of Dominican Republic in 1991 to that in 1994?
Your answer should be compact. 1.02. What is the ratio of the Value added (% of GDP) in Myanmar in 1991 to that in 1994?
Make the answer very short. 1.14. What is the ratio of the Value added (% of GDP) of Uzbekistan in 1991 to that in 1994?
Your response must be concise. 1.38. What is the ratio of the Value added (% of GDP) of Middle income in 1991 to that in 1995?
Offer a very short reply. 0.97. What is the ratio of the Value added (% of GDP) of Dominican Republic in 1991 to that in 1995?
Provide a short and direct response. 1.04. What is the ratio of the Value added (% of GDP) in Myanmar in 1991 to that in 1995?
Make the answer very short. 1. What is the ratio of the Value added (% of GDP) in Uzbekistan in 1991 to that in 1995?
Make the answer very short. 1.32. What is the ratio of the Value added (% of GDP) of Middle income in 1991 to that in 1996?
Provide a succinct answer. 0.97. What is the ratio of the Value added (% of GDP) in Myanmar in 1991 to that in 1996?
Give a very brief answer. 0.94. What is the ratio of the Value added (% of GDP) of Uzbekistan in 1991 to that in 1996?
Your response must be concise. 1.2. What is the ratio of the Value added (% of GDP) in Middle income in 1991 to that in 1997?
Ensure brevity in your answer.  0.97. What is the ratio of the Value added (% of GDP) in Myanmar in 1991 to that in 1997?
Your answer should be compact. 0.97. What is the ratio of the Value added (% of GDP) of Uzbekistan in 1991 to that in 1997?
Provide a short and direct response. 1.4. What is the ratio of the Value added (% of GDP) in Middle income in 1991 to that in 1998?
Your response must be concise. 1. What is the ratio of the Value added (% of GDP) in Dominican Republic in 1991 to that in 1998?
Offer a very short reply. 1.01. What is the ratio of the Value added (% of GDP) of Myanmar in 1991 to that in 1998?
Your answer should be compact. 1. What is the ratio of the Value added (% of GDP) of Uzbekistan in 1991 to that in 1998?
Make the answer very short. 1.4. What is the ratio of the Value added (% of GDP) in Middle income in 1992 to that in 1993?
Provide a short and direct response. 0.97. What is the ratio of the Value added (% of GDP) of Dominican Republic in 1992 to that in 1993?
Offer a terse response. 1.01. What is the ratio of the Value added (% of GDP) of Myanmar in 1992 to that in 1993?
Your answer should be very brief. 1.06. What is the ratio of the Value added (% of GDP) of Uzbekistan in 1992 to that in 1993?
Your response must be concise. 1.04. What is the ratio of the Value added (% of GDP) in Middle income in 1992 to that in 1994?
Make the answer very short. 0.97. What is the ratio of the Value added (% of GDP) in Dominican Republic in 1992 to that in 1994?
Offer a terse response. 0.99. What is the ratio of the Value added (% of GDP) in Myanmar in 1992 to that in 1994?
Your answer should be very brief. 1.09. What is the ratio of the Value added (% of GDP) of Uzbekistan in 1992 to that in 1994?
Your answer should be very brief. 1.35. What is the ratio of the Value added (% of GDP) of Middle income in 1992 to that in 1995?
Provide a succinct answer. 0.99. What is the ratio of the Value added (% of GDP) of Myanmar in 1992 to that in 1995?
Keep it short and to the point. 0.96. What is the ratio of the Value added (% of GDP) in Uzbekistan in 1992 to that in 1995?
Provide a short and direct response. 1.29. What is the ratio of the Value added (% of GDP) in Dominican Republic in 1992 to that in 1996?
Provide a succinct answer. 0.97. What is the ratio of the Value added (% of GDP) of Myanmar in 1992 to that in 1996?
Provide a short and direct response. 0.9. What is the ratio of the Value added (% of GDP) in Uzbekistan in 1992 to that in 1996?
Your answer should be compact. 1.17. What is the ratio of the Value added (% of GDP) in Myanmar in 1992 to that in 1997?
Offer a very short reply. 0.93. What is the ratio of the Value added (% of GDP) of Uzbekistan in 1992 to that in 1997?
Your response must be concise. 1.37. What is the ratio of the Value added (% of GDP) of Middle income in 1992 to that in 1998?
Provide a succinct answer. 1.02. What is the ratio of the Value added (% of GDP) of Dominican Republic in 1992 to that in 1998?
Provide a succinct answer. 0.99. What is the ratio of the Value added (% of GDP) in Myanmar in 1992 to that in 1998?
Provide a short and direct response. 0.96. What is the ratio of the Value added (% of GDP) in Uzbekistan in 1992 to that in 1998?
Your answer should be very brief. 1.37. What is the ratio of the Value added (% of GDP) of Dominican Republic in 1993 to that in 1994?
Provide a short and direct response. 0.98. What is the ratio of the Value added (% of GDP) in Myanmar in 1993 to that in 1994?
Keep it short and to the point. 1.03. What is the ratio of the Value added (% of GDP) of Uzbekistan in 1993 to that in 1994?
Keep it short and to the point. 1.3. What is the ratio of the Value added (% of GDP) in Middle income in 1993 to that in 1995?
Your answer should be very brief. 1.02. What is the ratio of the Value added (% of GDP) in Dominican Republic in 1993 to that in 1995?
Ensure brevity in your answer.  1. What is the ratio of the Value added (% of GDP) of Myanmar in 1993 to that in 1995?
Your answer should be very brief. 0.9. What is the ratio of the Value added (% of GDP) in Uzbekistan in 1993 to that in 1995?
Keep it short and to the point. 1.24. What is the ratio of the Value added (% of GDP) in Middle income in 1993 to that in 1996?
Your answer should be compact. 1.02. What is the ratio of the Value added (% of GDP) in Dominican Republic in 1993 to that in 1996?
Your answer should be compact. 0.96. What is the ratio of the Value added (% of GDP) in Myanmar in 1993 to that in 1996?
Your answer should be very brief. 0.86. What is the ratio of the Value added (% of GDP) of Uzbekistan in 1993 to that in 1996?
Keep it short and to the point. 1.13. What is the ratio of the Value added (% of GDP) of Middle income in 1993 to that in 1997?
Keep it short and to the point. 1.03. What is the ratio of the Value added (% of GDP) in Myanmar in 1993 to that in 1997?
Ensure brevity in your answer.  0.88. What is the ratio of the Value added (% of GDP) of Uzbekistan in 1993 to that in 1997?
Your response must be concise. 1.32. What is the ratio of the Value added (% of GDP) of Middle income in 1993 to that in 1998?
Keep it short and to the point. 1.05. What is the ratio of the Value added (% of GDP) of Dominican Republic in 1993 to that in 1998?
Offer a very short reply. 0.98. What is the ratio of the Value added (% of GDP) of Myanmar in 1993 to that in 1998?
Provide a short and direct response. 0.91. What is the ratio of the Value added (% of GDP) in Uzbekistan in 1993 to that in 1998?
Your response must be concise. 1.32. What is the ratio of the Value added (% of GDP) in Middle income in 1994 to that in 1995?
Offer a terse response. 1.02. What is the ratio of the Value added (% of GDP) of Dominican Republic in 1994 to that in 1995?
Make the answer very short. 1.02. What is the ratio of the Value added (% of GDP) of Myanmar in 1994 to that in 1995?
Your response must be concise. 0.88. What is the ratio of the Value added (% of GDP) in Uzbekistan in 1994 to that in 1995?
Your response must be concise. 0.95. What is the ratio of the Value added (% of GDP) in Middle income in 1994 to that in 1996?
Provide a succinct answer. 1.02. What is the ratio of the Value added (% of GDP) of Dominican Republic in 1994 to that in 1996?
Ensure brevity in your answer.  0.98. What is the ratio of the Value added (% of GDP) in Myanmar in 1994 to that in 1996?
Ensure brevity in your answer.  0.83. What is the ratio of the Value added (% of GDP) of Uzbekistan in 1994 to that in 1996?
Ensure brevity in your answer.  0.87. What is the ratio of the Value added (% of GDP) of Middle income in 1994 to that in 1997?
Give a very brief answer. 1.02. What is the ratio of the Value added (% of GDP) in Dominican Republic in 1994 to that in 1997?
Make the answer very short. 1.01. What is the ratio of the Value added (% of GDP) of Myanmar in 1994 to that in 1997?
Make the answer very short. 0.85. What is the ratio of the Value added (% of GDP) in Uzbekistan in 1994 to that in 1997?
Give a very brief answer. 1.01. What is the ratio of the Value added (% of GDP) of Middle income in 1994 to that in 1998?
Give a very brief answer. 1.05. What is the ratio of the Value added (% of GDP) of Myanmar in 1994 to that in 1998?
Your answer should be compact. 0.88. What is the ratio of the Value added (% of GDP) in Uzbekistan in 1994 to that in 1998?
Provide a succinct answer. 1.01. What is the ratio of the Value added (% of GDP) of Dominican Republic in 1995 to that in 1996?
Your answer should be very brief. 0.96. What is the ratio of the Value added (% of GDP) of Myanmar in 1995 to that in 1996?
Your response must be concise. 0.95. What is the ratio of the Value added (% of GDP) in Uzbekistan in 1995 to that in 1996?
Your answer should be compact. 0.91. What is the ratio of the Value added (% of GDP) in Middle income in 1995 to that in 1997?
Your response must be concise. 1. What is the ratio of the Value added (% of GDP) of Dominican Republic in 1995 to that in 1997?
Your answer should be compact. 0.99. What is the ratio of the Value added (% of GDP) of Myanmar in 1995 to that in 1997?
Offer a very short reply. 0.97. What is the ratio of the Value added (% of GDP) of Uzbekistan in 1995 to that in 1997?
Offer a terse response. 1.06. What is the ratio of the Value added (% of GDP) of Middle income in 1995 to that in 1998?
Provide a short and direct response. 1.03. What is the ratio of the Value added (% of GDP) in Dominican Republic in 1995 to that in 1998?
Offer a very short reply. 0.98. What is the ratio of the Value added (% of GDP) in Uzbekistan in 1995 to that in 1998?
Your answer should be very brief. 1.06. What is the ratio of the Value added (% of GDP) in Middle income in 1996 to that in 1997?
Ensure brevity in your answer.  1.01. What is the ratio of the Value added (% of GDP) of Dominican Republic in 1996 to that in 1997?
Keep it short and to the point. 1.03. What is the ratio of the Value added (% of GDP) of Myanmar in 1996 to that in 1997?
Make the answer very short. 1.03. What is the ratio of the Value added (% of GDP) of Uzbekistan in 1996 to that in 1997?
Make the answer very short. 1.17. What is the ratio of the Value added (% of GDP) of Middle income in 1996 to that in 1998?
Offer a terse response. 1.03. What is the ratio of the Value added (% of GDP) of Dominican Republic in 1996 to that in 1998?
Your response must be concise. 1.02. What is the ratio of the Value added (% of GDP) in Myanmar in 1996 to that in 1998?
Ensure brevity in your answer.  1.06. What is the ratio of the Value added (% of GDP) in Uzbekistan in 1996 to that in 1998?
Ensure brevity in your answer.  1.16. What is the ratio of the Value added (% of GDP) of Middle income in 1997 to that in 1998?
Provide a succinct answer. 1.02. What is the ratio of the Value added (% of GDP) in Dominican Republic in 1997 to that in 1998?
Ensure brevity in your answer.  0.98. What is the ratio of the Value added (% of GDP) of Myanmar in 1997 to that in 1998?
Offer a very short reply. 1.03. What is the ratio of the Value added (% of GDP) in Uzbekistan in 1997 to that in 1998?
Make the answer very short. 1. What is the difference between the highest and the second highest Value added (% of GDP) of Middle income?
Ensure brevity in your answer.  0.12. What is the difference between the highest and the second highest Value added (% of GDP) of Dominican Republic?
Your answer should be compact. 0.08. What is the difference between the highest and the second highest Value added (% of GDP) of Myanmar?
Offer a very short reply. 0.27. What is the difference between the highest and the second highest Value added (% of GDP) of Uzbekistan?
Give a very brief answer. 0.76. What is the difference between the highest and the lowest Value added (% of GDP) in Middle income?
Your answer should be compact. 1.97. What is the difference between the highest and the lowest Value added (% of GDP) of Dominican Republic?
Ensure brevity in your answer.  1.29. What is the difference between the highest and the lowest Value added (% of GDP) in Myanmar?
Offer a very short reply. 1.79. What is the difference between the highest and the lowest Value added (% of GDP) in Uzbekistan?
Give a very brief answer. 10.46. 